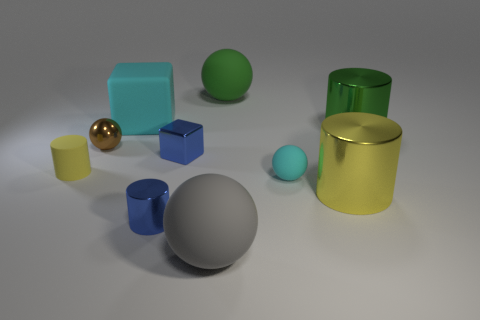Are there any objects that stand out due to their color or shape? The gold sphere stands out due to its shiny texture and unique color compared to the other objects. In terms of shape, the green cylinder is distinct because it is the only tall, round object among predominantly block-shaped items. 